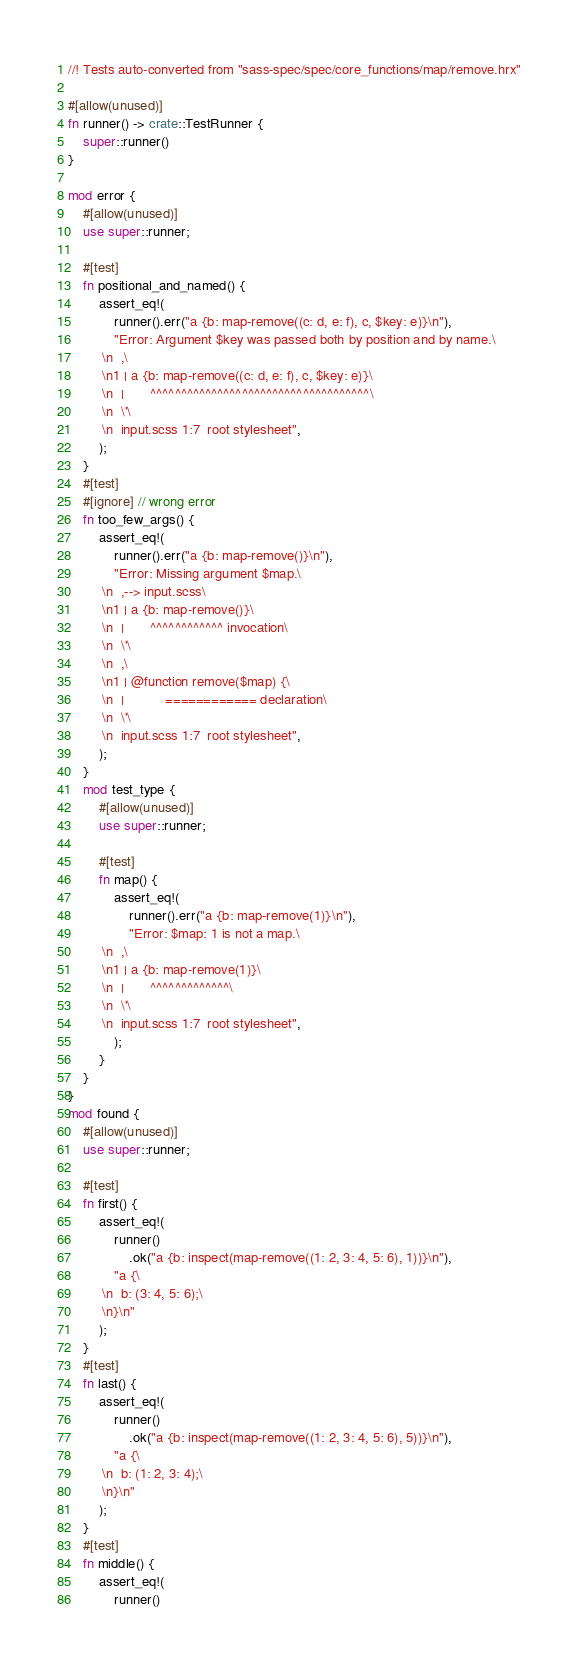<code> <loc_0><loc_0><loc_500><loc_500><_Rust_>//! Tests auto-converted from "sass-spec/spec/core_functions/map/remove.hrx"

#[allow(unused)]
fn runner() -> crate::TestRunner {
    super::runner()
}

mod error {
    #[allow(unused)]
    use super::runner;

    #[test]
    fn positional_and_named() {
        assert_eq!(
            runner().err("a {b: map-remove((c: d, e: f), c, $key: e)}\n"),
            "Error: Argument $key was passed both by position and by name.\
         \n  ,\
         \n1 | a {b: map-remove((c: d, e: f), c, $key: e)}\
         \n  |       ^^^^^^^^^^^^^^^^^^^^^^^^^^^^^^^^^^^^\
         \n  \'\
         \n  input.scss 1:7  root stylesheet",
        );
    }
    #[test]
    #[ignore] // wrong error
    fn too_few_args() {
        assert_eq!(
            runner().err("a {b: map-remove()}\n"),
            "Error: Missing argument $map.\
         \n  ,--> input.scss\
         \n1 | a {b: map-remove()}\
         \n  |       ^^^^^^^^^^^^ invocation\
         \n  \'\
         \n  ,\
         \n1 | @function remove($map) {\
         \n  |           ============ declaration\
         \n  \'\
         \n  input.scss 1:7  root stylesheet",
        );
    }
    mod test_type {
        #[allow(unused)]
        use super::runner;

        #[test]
        fn map() {
            assert_eq!(
                runner().err("a {b: map-remove(1)}\n"),
                "Error: $map: 1 is not a map.\
         \n  ,\
         \n1 | a {b: map-remove(1)}\
         \n  |       ^^^^^^^^^^^^^\
         \n  \'\
         \n  input.scss 1:7  root stylesheet",
            );
        }
    }
}
mod found {
    #[allow(unused)]
    use super::runner;

    #[test]
    fn first() {
        assert_eq!(
            runner()
                .ok("a {b: inspect(map-remove((1: 2, 3: 4, 5: 6), 1))}\n"),
            "a {\
         \n  b: (3: 4, 5: 6);\
         \n}\n"
        );
    }
    #[test]
    fn last() {
        assert_eq!(
            runner()
                .ok("a {b: inspect(map-remove((1: 2, 3: 4, 5: 6), 5))}\n"),
            "a {\
         \n  b: (1: 2, 3: 4);\
         \n}\n"
        );
    }
    #[test]
    fn middle() {
        assert_eq!(
            runner()</code> 